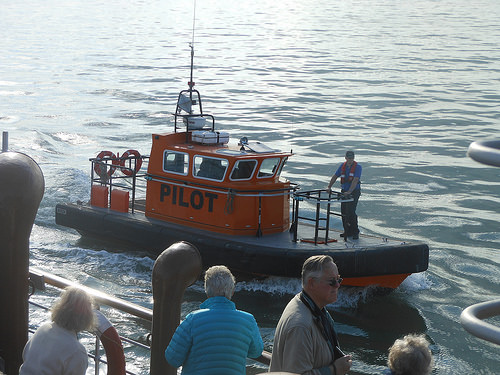<image>
Can you confirm if the man is on the boat? Yes. Looking at the image, I can see the man is positioned on top of the boat, with the boat providing support. Where is the sea in relation to the boat? Is it on the boat? No. The sea is not positioned on the boat. They may be near each other, but the sea is not supported by or resting on top of the boat. Where is the man in relation to the boat? Is it on the boat? No. The man is not positioned on the boat. They may be near each other, but the man is not supported by or resting on top of the boat. Is there a man to the left of the woman? No. The man is not to the left of the woman. From this viewpoint, they have a different horizontal relationship. 